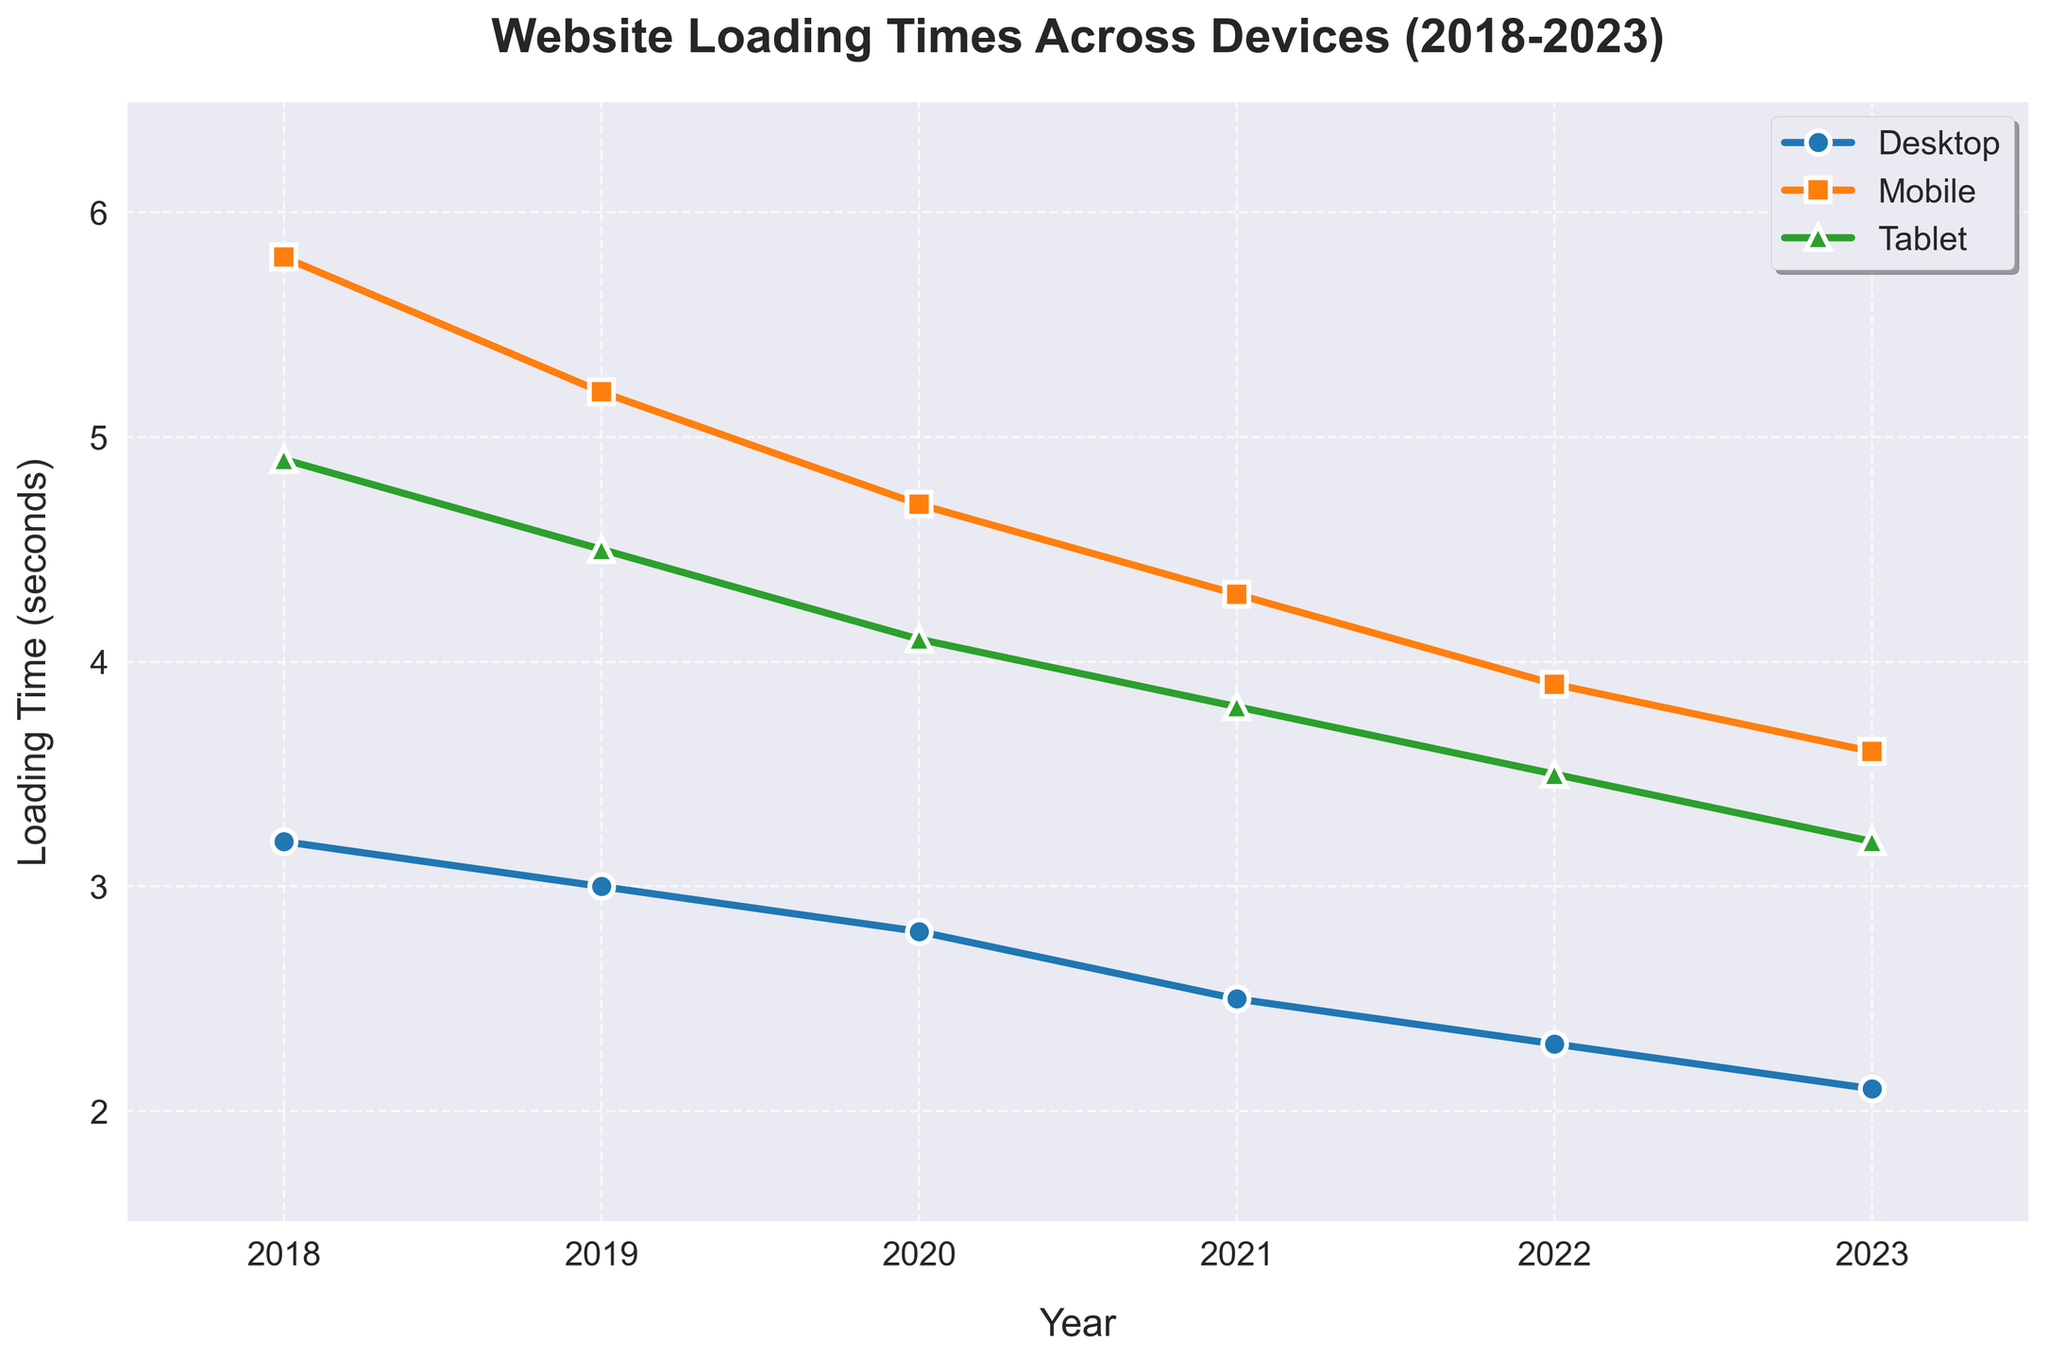What is the overall trend in website loading times for Desktop devices from 2018 to 2023? The figure shows a steady decline in the loading times for Desktop devices over the years. In 2018, it starts at 3.2 seconds and gradually decreases to 2.1 seconds in 2023.
Answer: Decreasing How did the loading time for Tablet devices change from 2021 to 2023? In 2021, the loading time was 3.8 seconds. It decreased to 3.5 seconds in 2022 and further decreased to 3.2 seconds in 2023.
Answer: Decreased Among Desktop, Mobile, and Tablet devices in 2023, which had the highest loading time and what was it? In 2023, the Mobile device had the highest loading time at 3.6 seconds.
Answer: Mobile, 3.6 seconds Between 2018 and 2020, by how many seconds did the loading time for Mobile devices decrease? In 2018, the loading time for Mobile devices was 5.8 seconds, and in 2020, it was 4.7 seconds. The decrease is 5.8 - 4.7 = 1.1 seconds.
Answer: 1.1 seconds Which device experienced the largest reduction in loading time from 2018 to 2023? Loading times for Desktop fell from 3.2 to 2.1 seconds (1.1 seconds), Mobile from 5.8 to 3.6 seconds (2.2 seconds), and Tablet from 4.9 to 3.2 seconds (1.7 seconds). Mobile had the largest reduction.
Answer: Mobile Comparing the loading times for Desktop and Tablet devices in 2019, which one loaded faster and by how much? In 2019, Desktop takes 3.0 seconds while Tablet takes 4.5 seconds. Desktop is faster by 4.5 - 3.0 = 1.5 seconds.
Answer: Desktop, 1.5 seconds What is the average loading time for Mobile devices over the 6 years shown in the figure? Add the Mobile loading times for each year: 5.8 + 5.2 + 4.7 + 4.3 + 3.9 + 3.6 = 27.5 seconds. Divide by 6 years to get the average: 27.5 / 6 ≈ 4.58 seconds.
Answer: ≈ 4.58 seconds During which year did Tablet devices see the highest year-over-year improvement in loading times, and what was the improvement? The biggest year-over-year improvement for Tablet was between 2018 and 2019 when loading time decreased from 4.9 to 4.5 seconds. The improvement was 4.9 - 4.5 = 0.4 seconds.
Answer: 2019, 0.4 seconds By what percentage did the Desktop loading time improve from 2020 to 2021? In 2020, Desktop loading time was 2.8 seconds, and in 2021, it was 2.5 seconds. Improvement is 2.8 - 2.5 = 0.3 seconds. Percentage improvement is (0.3 / 2.8) * 100 ≈ 10.71%.
Answer: ≈ 10.71% 